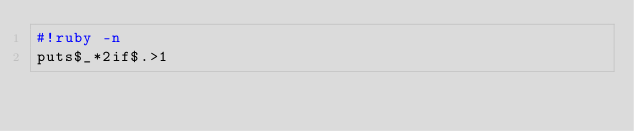Convert code to text. <code><loc_0><loc_0><loc_500><loc_500><_Ruby_>#!ruby -n
puts$_*2if$.>1</code> 